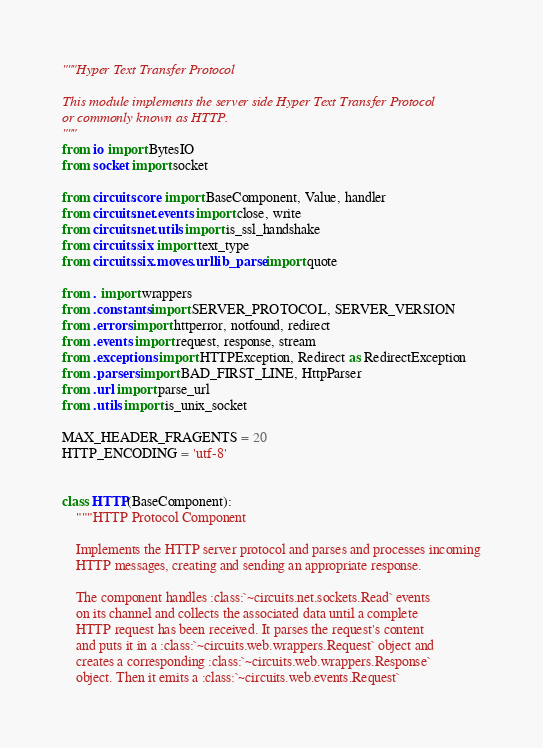<code> <loc_0><loc_0><loc_500><loc_500><_Python_>"""Hyper Text Transfer Protocol

This module implements the server side Hyper Text Transfer Protocol
or commonly known as HTTP.
"""
from io import BytesIO
from socket import socket

from circuits.core import BaseComponent, Value, handler
from circuits.net.events import close, write
from circuits.net.utils import is_ssl_handshake
from circuits.six import text_type
from circuits.six.moves.urllib_parse import quote

from . import wrappers
from .constants import SERVER_PROTOCOL, SERVER_VERSION
from .errors import httperror, notfound, redirect
from .events import request, response, stream
from .exceptions import HTTPException, Redirect as RedirectException
from .parsers import BAD_FIRST_LINE, HttpParser
from .url import parse_url
from .utils import is_unix_socket

MAX_HEADER_FRAGENTS = 20
HTTP_ENCODING = 'utf-8'


class HTTP(BaseComponent):
    """HTTP Protocol Component

    Implements the HTTP server protocol and parses and processes incoming
    HTTP messages, creating and sending an appropriate response.

    The component handles :class:`~circuits.net.sockets.Read` events
    on its channel and collects the associated data until a complete
    HTTP request has been received. It parses the request's content
    and puts it in a :class:`~circuits.web.wrappers.Request` object and
    creates a corresponding :class:`~circuits.web.wrappers.Response`
    object. Then it emits a :class:`~circuits.web.events.Request`</code> 